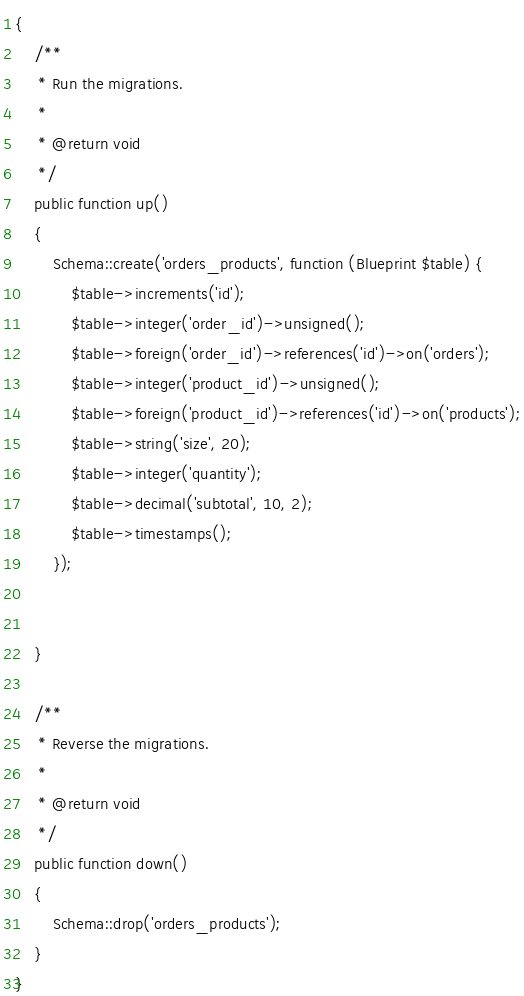<code> <loc_0><loc_0><loc_500><loc_500><_PHP_>{
    /**
     * Run the migrations.
     *
     * @return void
     */
    public function up()
    {   
        Schema::create('orders_products', function (Blueprint $table) {
            $table->increments('id');
            $table->integer('order_id')->unsigned();
            $table->foreign('order_id')->references('id')->on('orders');
            $table->integer('product_id')->unsigned();
            $table->foreign('product_id')->references('id')->on('products');
            $table->string('size', 20);
            $table->integer('quantity');
            $table->decimal('subtotal', 10, 2);
            $table->timestamps();
        });

       
    }

    /**
     * Reverse the migrations.
     *
     * @return void
     */
    public function down()
    {
        Schema::drop('orders_products');
    }
}
</code> 